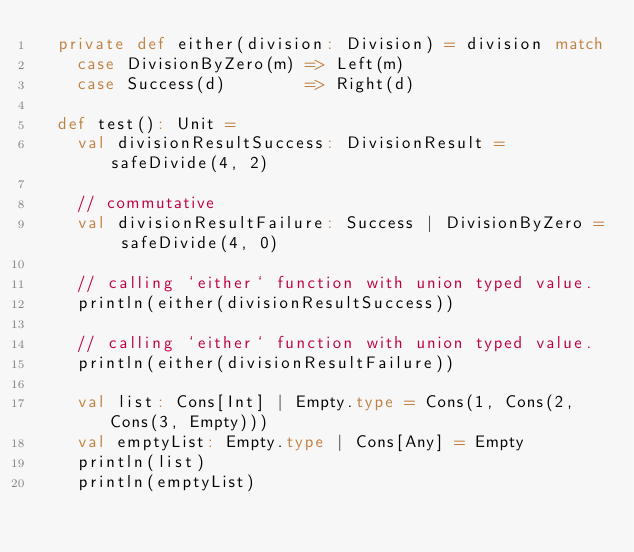Convert code to text. <code><loc_0><loc_0><loc_500><loc_500><_Scala_>  private def either(division: Division) = division match
    case DivisionByZero(m) => Left(m)
    case Success(d)        => Right(d)

  def test(): Unit =
    val divisionResultSuccess: DivisionResult = safeDivide(4, 2)

    // commutative
    val divisionResultFailure: Success | DivisionByZero = safeDivide(4, 0)

    // calling `either` function with union typed value.
    println(either(divisionResultSuccess))

    // calling `either` function with union typed value.
    println(either(divisionResultFailure))

    val list: Cons[Int] | Empty.type = Cons(1, Cons(2, Cons(3, Empty)))
    val emptyList: Empty.type | Cons[Any] = Empty
    println(list)
    println(emptyList)

</code> 